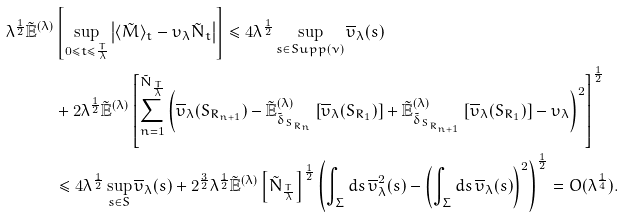Convert formula to latex. <formula><loc_0><loc_0><loc_500><loc_500>\lambda ^ { \frac { 1 } { 2 } } \tilde { \mathbb { E } } ^ { ( \lambda ) } & \left [ \sup _ { 0 \leq t \leq \frac { T } { \lambda } } \left | \langle \tilde { M } \rangle _ { t } - \upsilon _ { \lambda } \tilde { N } _ { t } \right | \right ] \leq 4 \lambda ^ { \frac { 1 } { 2 } } \sup _ { s \in S u p p ( \nu ) } \overline { \upsilon } _ { \lambda } ( s ) \\ & + 2 \lambda ^ { \frac { 1 } { 2 } } \tilde { \mathbb { E } } ^ { ( \lambda ) } \left [ \sum _ { n = 1 } ^ { \tilde { N } _ { \frac { T } { \lambda } } } \left ( \overline { \upsilon } _ { \lambda } ( S _ { R _ { n + 1 } } ) - \tilde { \mathbb { E } } ^ { ( \lambda ) } _ { \tilde { \delta } _ { S _ { R _ { n } } } } \left [ \overline { \upsilon } _ { \lambda } ( S _ { R _ { 1 } } ) \right ] + \tilde { \mathbb { E } } ^ { ( \lambda ) } _ { \tilde { \delta } _ { S _ { R _ { n + 1 } } } } \left [ \overline { \upsilon } _ { \lambda } ( S _ { R _ { 1 } } ) \right ] - \upsilon _ { \lambda } \right ) ^ { 2 } \right ] ^ { \frac { 1 } { 2 } } \\ & \leq 4 \lambda ^ { \frac { 1 } { 2 } } \sup _ { s \in S } \overline { \upsilon } _ { \lambda } ( s ) + 2 ^ { \frac { 3 } { 2 } } \lambda ^ { \frac { 1 } { 2 } } \tilde { \mathbb { E } } ^ { ( \lambda ) } \left [ \tilde { N } _ { \frac { T } { \lambda } } \right ] ^ { \frac { 1 } { 2 } } \left ( \int _ { \Sigma } d s \, \overline { \upsilon } ^ { 2 } _ { \lambda } ( s ) - \left ( \int _ { \Sigma } d s \, \overline { \upsilon } _ { \lambda } ( s ) \right ) ^ { 2 } \right ) ^ { \frac { 1 } { 2 } } = O ( \lambda ^ { \frac { 1 } { 4 } } ) .</formula> 